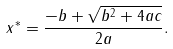Convert formula to latex. <formula><loc_0><loc_0><loc_500><loc_500>x ^ { * } = \frac { - b + \sqrt { b ^ { 2 } + 4 a c } } { 2 a } .</formula> 